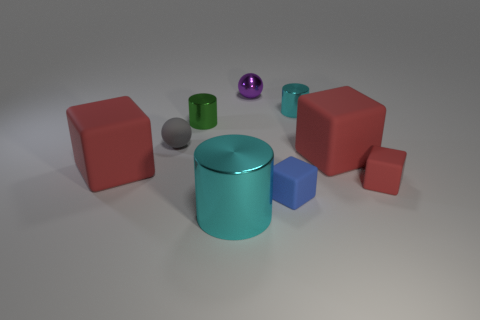Subtract all blue cubes. How many cubes are left? 3 Add 1 cyan things. How many objects exist? 10 Subtract 1 balls. How many balls are left? 1 Subtract all cyan cubes. How many cyan cylinders are left? 2 Subtract all purple spheres. How many spheres are left? 1 Subtract 0 brown cubes. How many objects are left? 9 Subtract all cubes. How many objects are left? 5 Subtract all blue cubes. Subtract all gray balls. How many cubes are left? 3 Subtract all blue objects. Subtract all red objects. How many objects are left? 5 Add 2 green cylinders. How many green cylinders are left? 3 